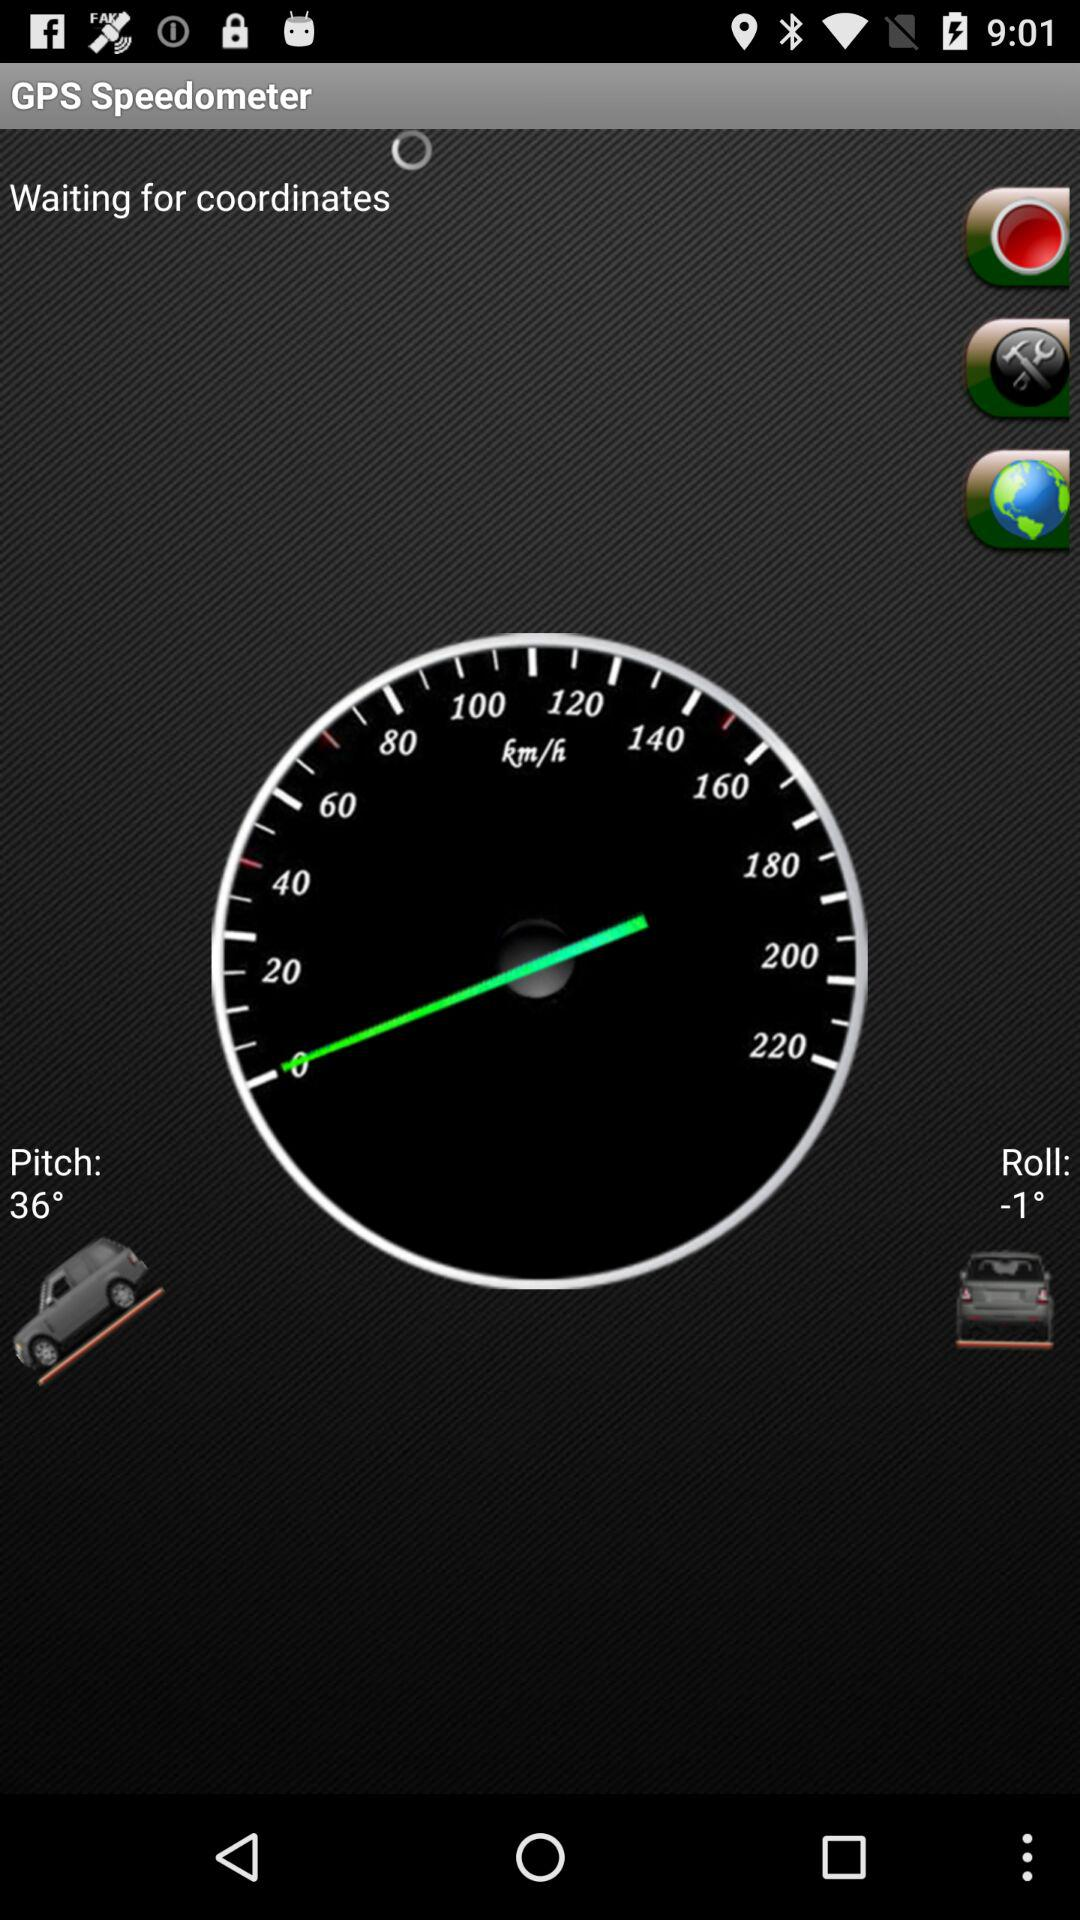How many degrees is the difference between the pitch and roll?
Answer the question using a single word or phrase. 37 